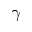Convert formula to latex. <formula><loc_0><loc_0><loc_500><loc_500>\gamma</formula> 